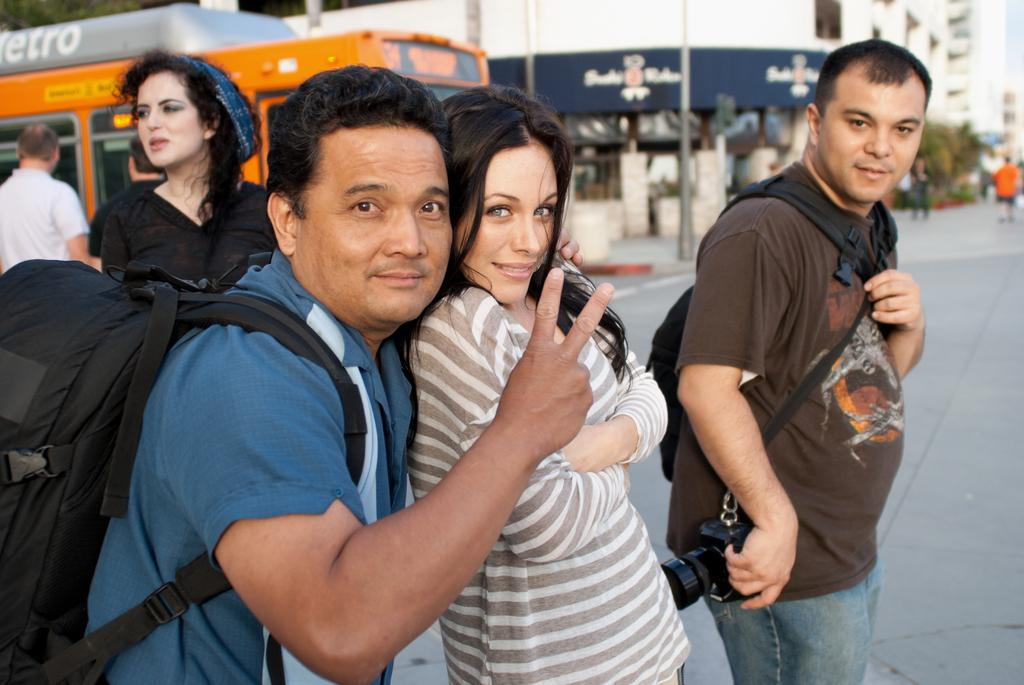What is the main subject of the picture? The main subject of the picture is people. Can you describe the people in the picture? There are men and women in the picture. What is visible in the background of the picture? There is a building in the background of the picture. What type of finger can be seen in the picture? There is no finger visible in the picture. What kind of spade is being used by the people in the picture? There is no spade present in the picture. 